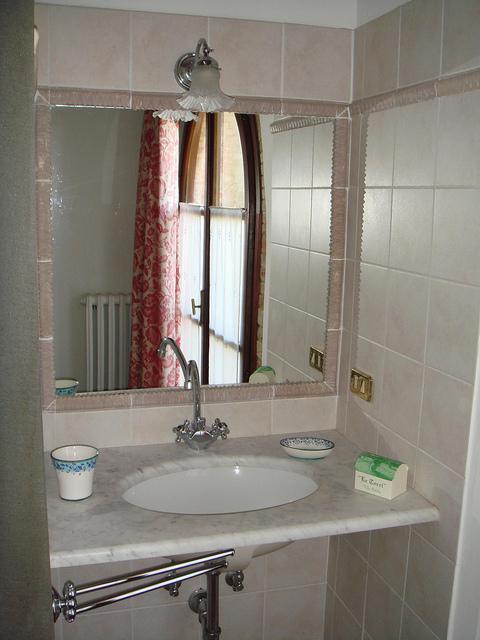How many mirror are in this picture?
Give a very brief answer. 1. How many men have sleeveless shirts?
Give a very brief answer. 0. 